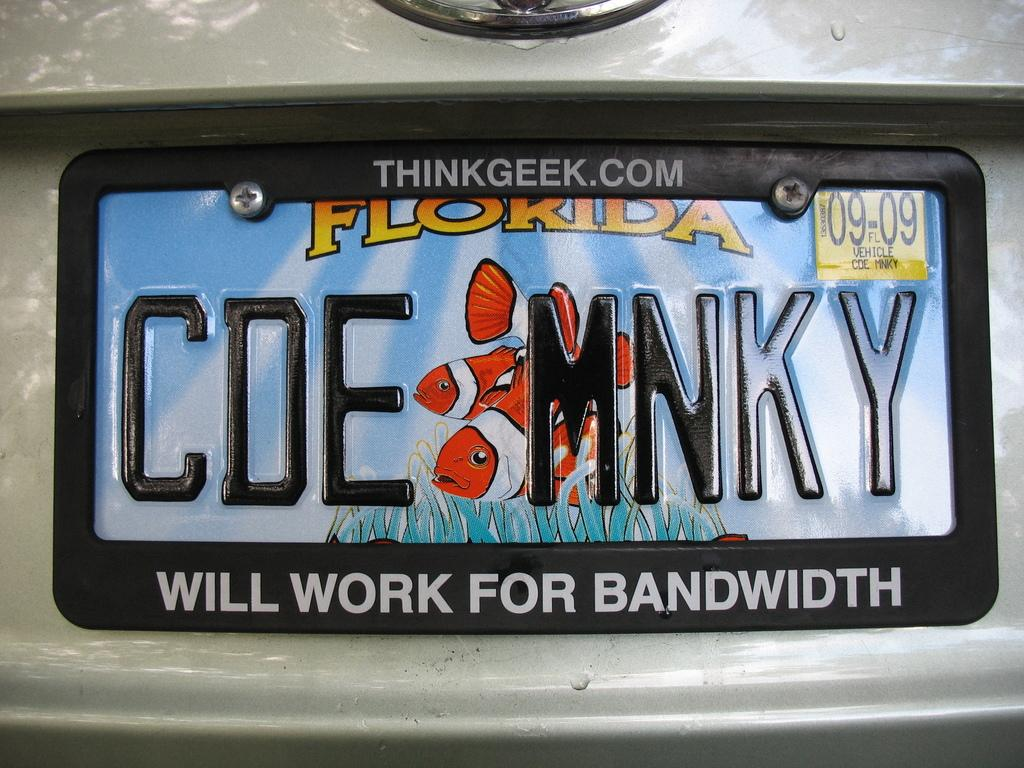<image>
Relay a brief, clear account of the picture shown. A Florida license plate "CDE MNKY" is displayed in a licence plate frame from "Thinkgeek.com." 